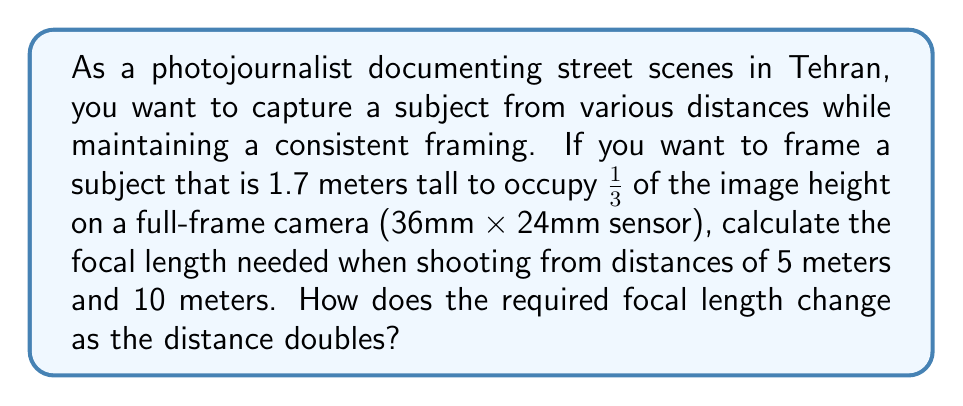Help me with this question. To solve this problem, we'll use the following steps:

1. Calculate the height of the subject in the frame:
   The subject should occupy 1/3 of the image height.
   Image height = 24mm (full-frame sensor)
   Subject height in frame = $\frac{1}{3} \times 24\text{mm} = 8\text{mm}$

2. Use the lens formula to calculate the focal length:
   $$\text{Focal Length} = \frac{\text{Subject Height in Frame} \times \text{Distance to Subject}}{\text{Actual Subject Height}}$$

3. For 5 meters distance:
   $$f_5 = \frac{8\text{mm} \times 5000\text{mm}}{1700\text{mm}} \approx 23.53\text{mm}$$

4. For 10 meters distance:
   $$f_{10} = \frac{8\text{mm} \times 10000\text{mm}}{1700\text{mm}} \approx 47.06\text{mm}$$

5. Analyze the change in focal length:
   The focal length at 10 meters is exactly twice the focal length at 5 meters.
   This is because the distance doubled while keeping the framing constant.

6. Generalize the relationship:
   For a given framing, the focal length is directly proportional to the distance to the subject. If the distance doubles, the required focal length also doubles.

   $$\frac{f_2}{f_1} = \frac{d_2}{d_1}$$

   Where $f_1$ and $f_2$ are focal lengths, and $d_1$ and $d_2$ are corresponding distances.
Answer: The required focal lengths are approximately 23.53mm at 5 meters and 47.06mm at 10 meters. When the distance doubles, the required focal length also doubles to maintain the same framing. 